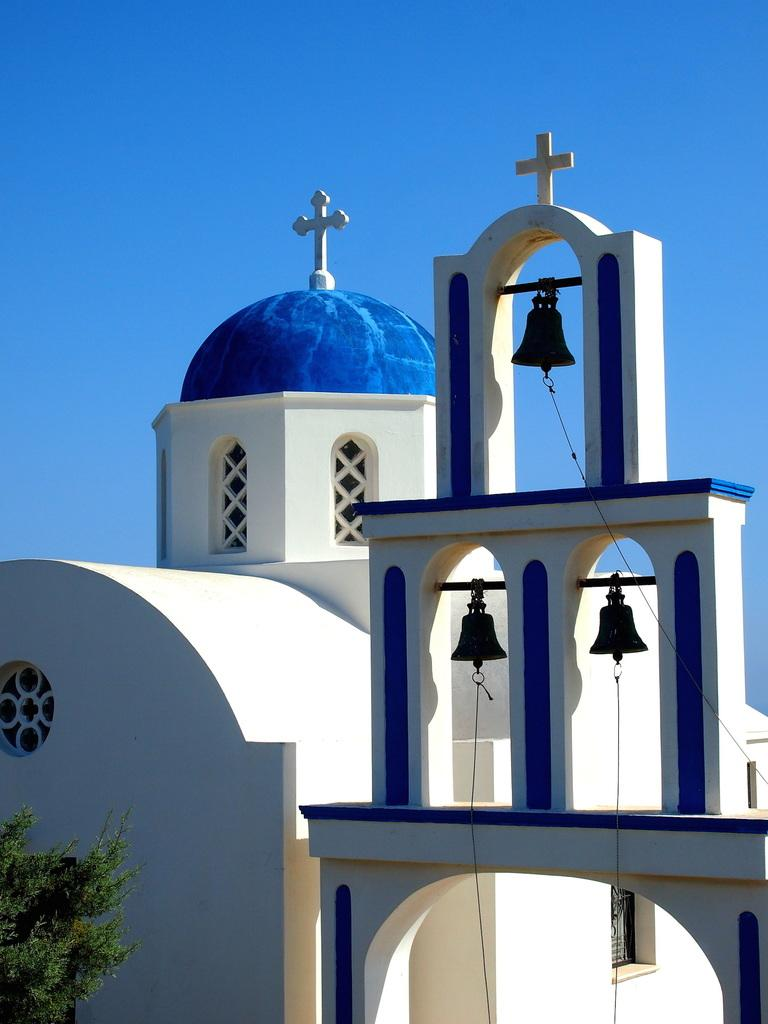What type of structure is visible in the image? There is a building in the image. What objects can be seen hanging from the building? There are bells in the image. What religious symbol is present in the image? There are cross symbols in the image. What type of vegetation is in front of the building? There is a tree in front of the building. What can be seen in the background of the image? The background of the image includes a blue sky. How many women are depicted in the image? There are no women present in the image. What type of bubble can be seen floating near the tree? There is no bubble present in the image. 